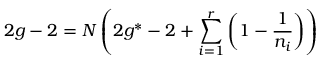<formula> <loc_0><loc_0><loc_500><loc_500>2 g - 2 = N \left ( 2 g ^ { * } - 2 + \sum _ { i = 1 } ^ { r } \left ( 1 - \frac { 1 } { n _ { i } } \right ) \right )</formula> 